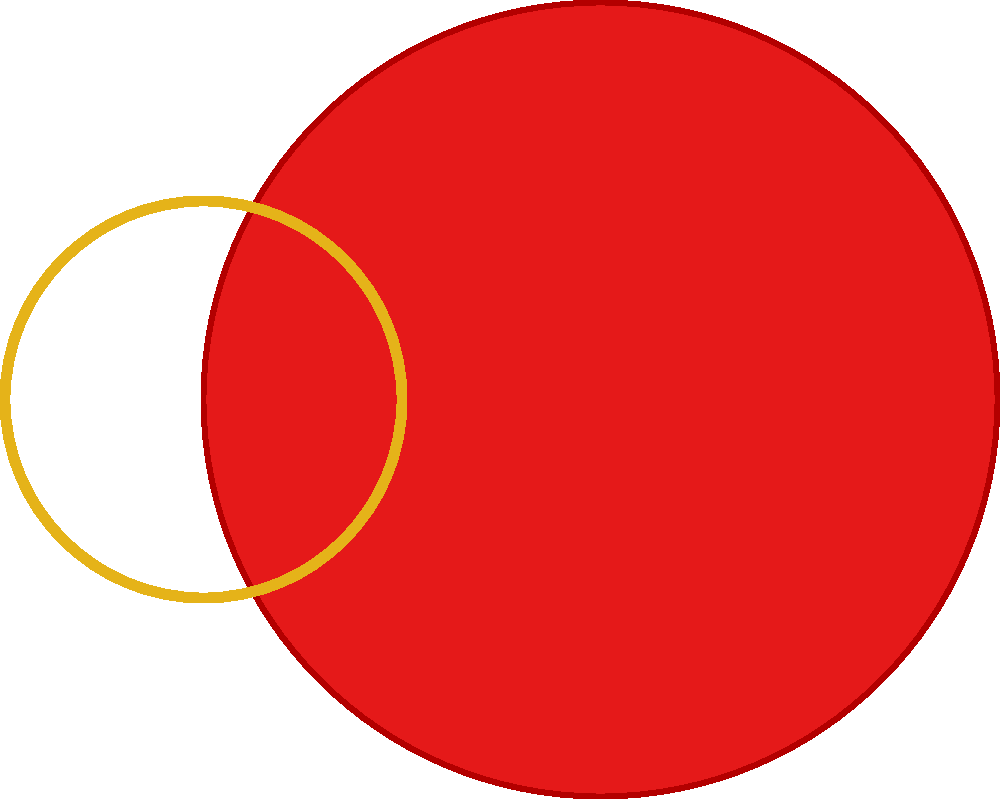In creating a modern vector interpretation of a traditional Ukrainian sunflower motif, which geometric transformation would be most effective for achieving radial symmetry in the petal arrangement? To create a modern vector interpretation of a Ukrainian sunflower motif with radial symmetry, follow these steps:

1. Start by designing a single petal shape using vector paths.
2. Determine the number of petals needed for the sunflower (typically 5 or more).
3. Calculate the angle of rotation between each petal: $\theta = \frac{360°}{n}$, where $n$ is the number of petals.
4. Apply a rotation transformation to the original petal, repeating it $n$ times, each time rotating by an additional $\theta$ degrees.
5. This rotation can be expressed mathematically as:
   $$ \begin{pmatrix} \cos(\theta) & -\sin(\theta) \\ \sin(\theta) & \cos(\theta) \end{pmatrix} \begin{pmatrix} x \\ y \end{pmatrix} $$
   where $(x,y)$ are the coordinates of points in the original petal.
6. The center of rotation should be the center of the flower.
7. After rotating all petals, add a central circle to represent the flower's center.

This process creates a radially symmetric arrangement, which is characteristic of sunflower motifs in Ukrainian folk art. The rotation transformation ensures that each petal is precisely positioned around the center, creating a balanced and aesthetically pleasing design.
Answer: Rotation transformation 